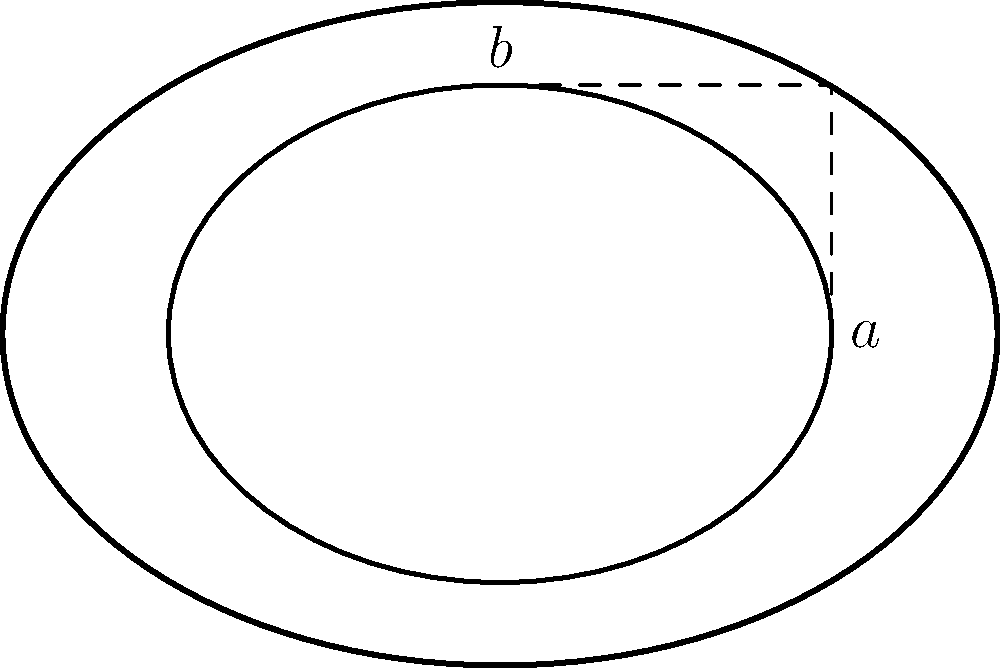A dental filling on the occlusal surface of a molar has an elliptical shape. The semi-major axis ($a$) of the ellipse is 2 mm, and the semi-minor axis ($b$) is 1.5 mm. Using the trigonometric form of the area of an ellipse, $A = \pi ab(\sin^2 \theta + \cos^2 \theta)$, calculate the area of the filling in square millimeters. To solve this problem, we'll follow these steps:

1) We are given the semi-major axis $a = 2$ mm and the semi-minor axis $b = 1.5$ mm.

2) The formula for the area of an ellipse using trigonometric functions is:

   $A = \pi ab(\sin^2 \theta + \cos^2 \theta)$

3) We know that $\sin^2 \theta + \cos^2 \theta = 1$ for any angle $\theta$ (this is a fundamental trigonometric identity).

4) Substituting this into our formula:

   $A = \pi ab(1)$

5) Now we can simply multiply the values:

   $A = \pi \cdot 2 \cdot 1.5$

6) Simplifying:

   $A = 3\pi$ mm²

Therefore, the area of the elliptical dental filling is $3\pi$ square millimeters.
Answer: $3\pi$ mm² 